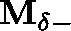Convert formula to latex. <formula><loc_0><loc_0><loc_500><loc_500>M _ { \delta - }</formula> 